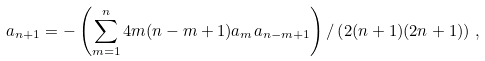<formula> <loc_0><loc_0><loc_500><loc_500>a _ { n + 1 } = - \left ( \sum _ { m = 1 } ^ { n } 4 m ( n - m + 1 ) a _ { m } a _ { n - m + 1 } \right ) / \left ( 2 ( n + 1 ) ( 2 n + 1 ) \right ) \, ,</formula> 